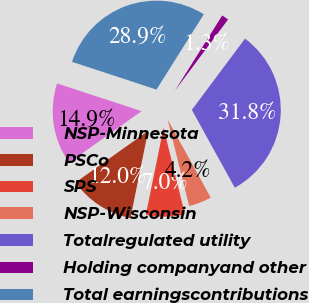Convert chart. <chart><loc_0><loc_0><loc_500><loc_500><pie_chart><fcel>NSP-Minnesota<fcel>PSCo<fcel>SPS<fcel>NSP-Wisconsin<fcel>Totalregulated utility<fcel>Holding companyand other<fcel>Total earningscontributions<nl><fcel>14.88%<fcel>11.99%<fcel>7.05%<fcel>4.16%<fcel>31.77%<fcel>1.27%<fcel>28.89%<nl></chart> 